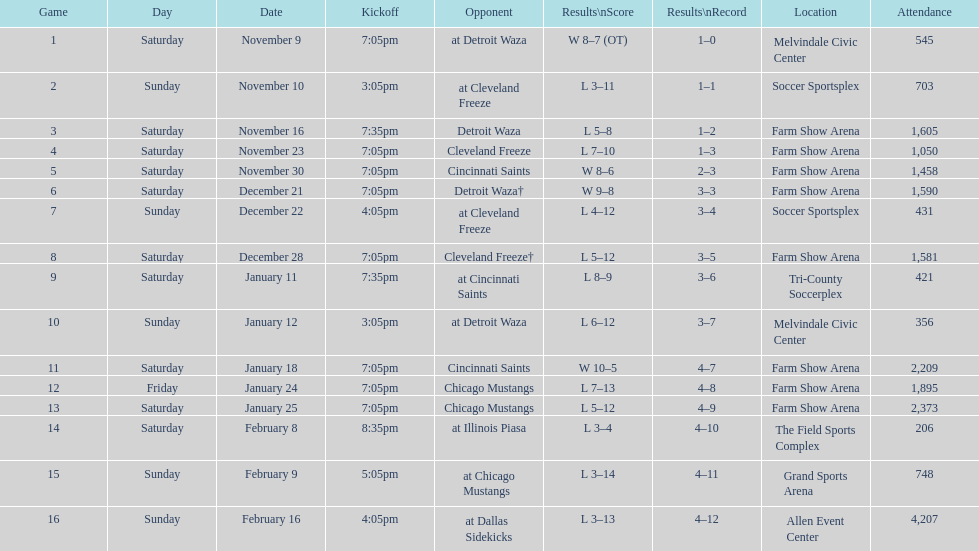How many times did the team participate at home without securing a win? 5. 